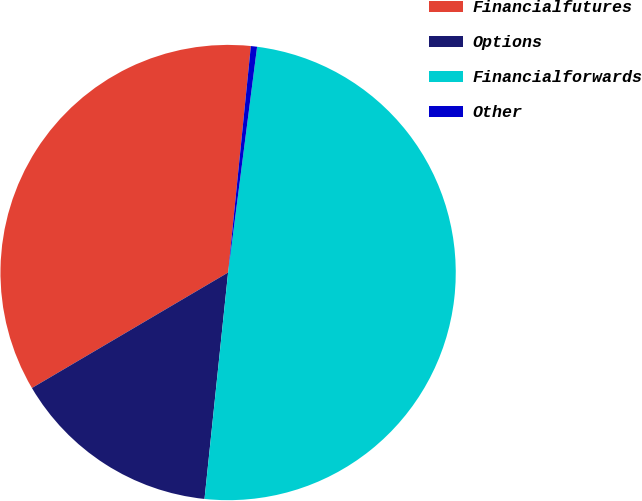Convert chart. <chart><loc_0><loc_0><loc_500><loc_500><pie_chart><fcel>Financialfutures<fcel>Options<fcel>Financialforwards<fcel>Other<nl><fcel>35.06%<fcel>14.88%<fcel>49.62%<fcel>0.44%<nl></chart> 